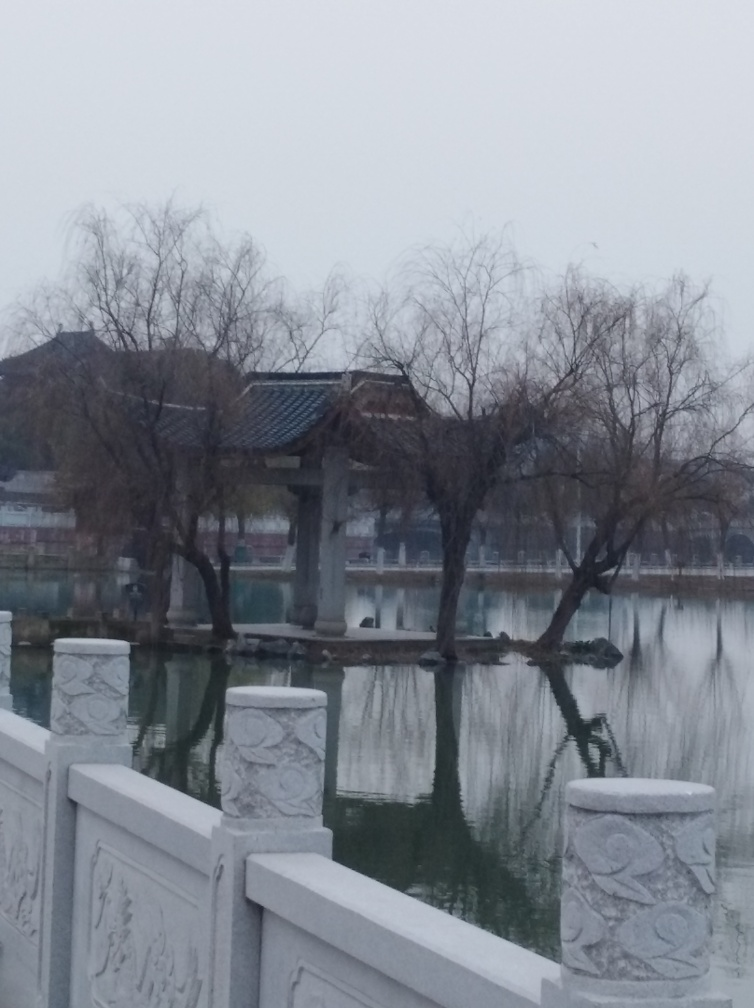How might the weather or season be described based on the trees’ appearance? The trees in the image appear bare, lacking leaves, which typically indicates that the photo was taken in a colder season, possibly autumn or winter, depending on the regional climate. The overcast sky and absence of snow or green foliage support this observation, suggesting a dormant period for vegetation. 